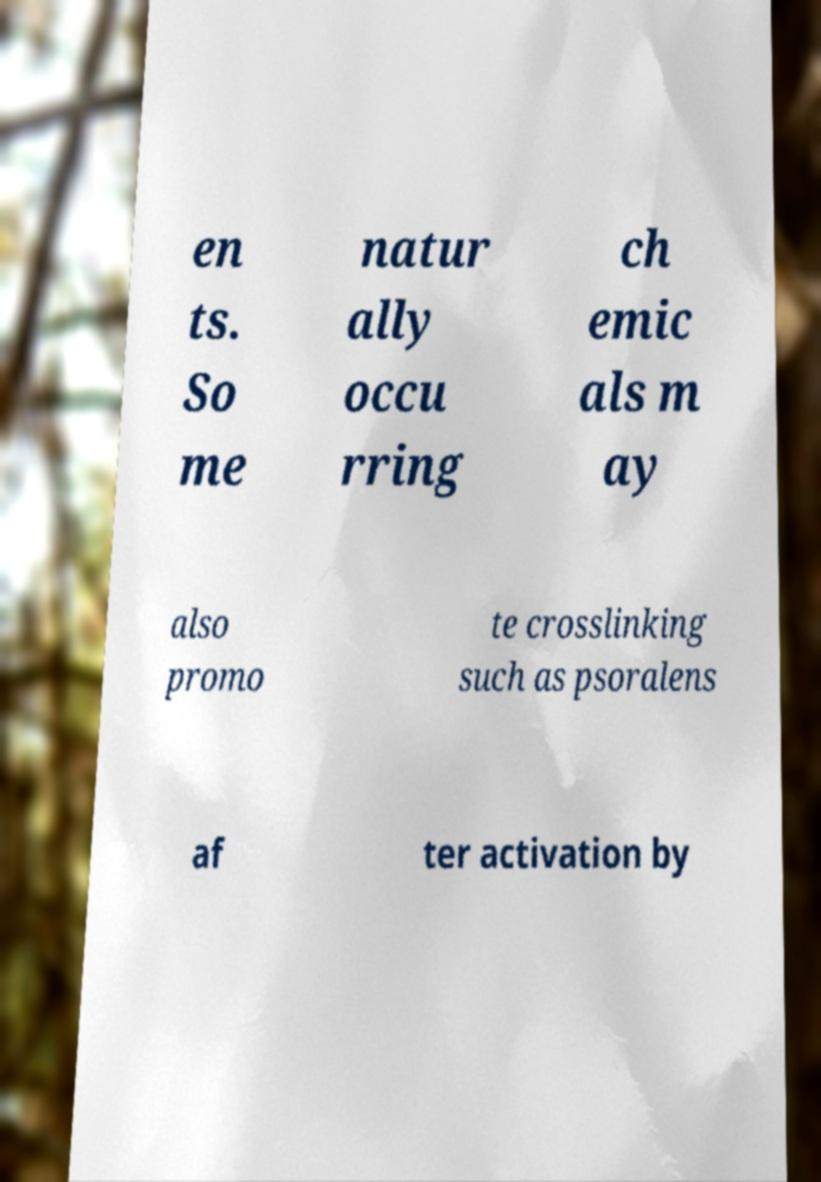Please identify and transcribe the text found in this image. en ts. So me natur ally occu rring ch emic als m ay also promo te crosslinking such as psoralens af ter activation by 